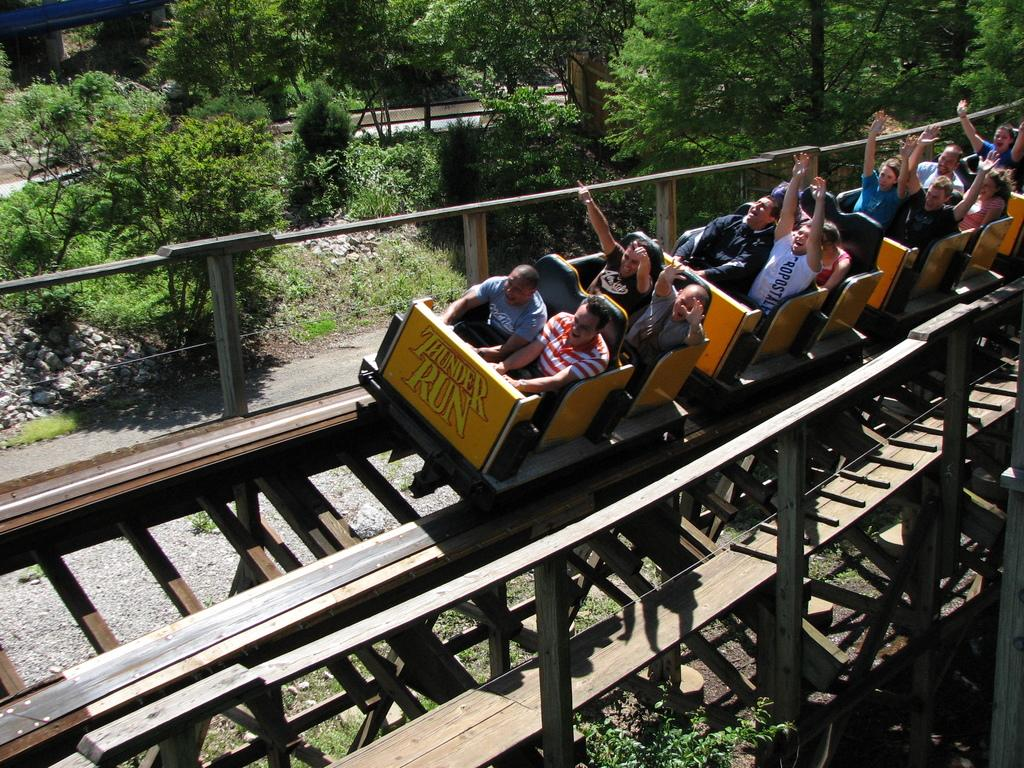<image>
Provide a brief description of the given image. A group of people enjoy the thunder run rollercoaster. 